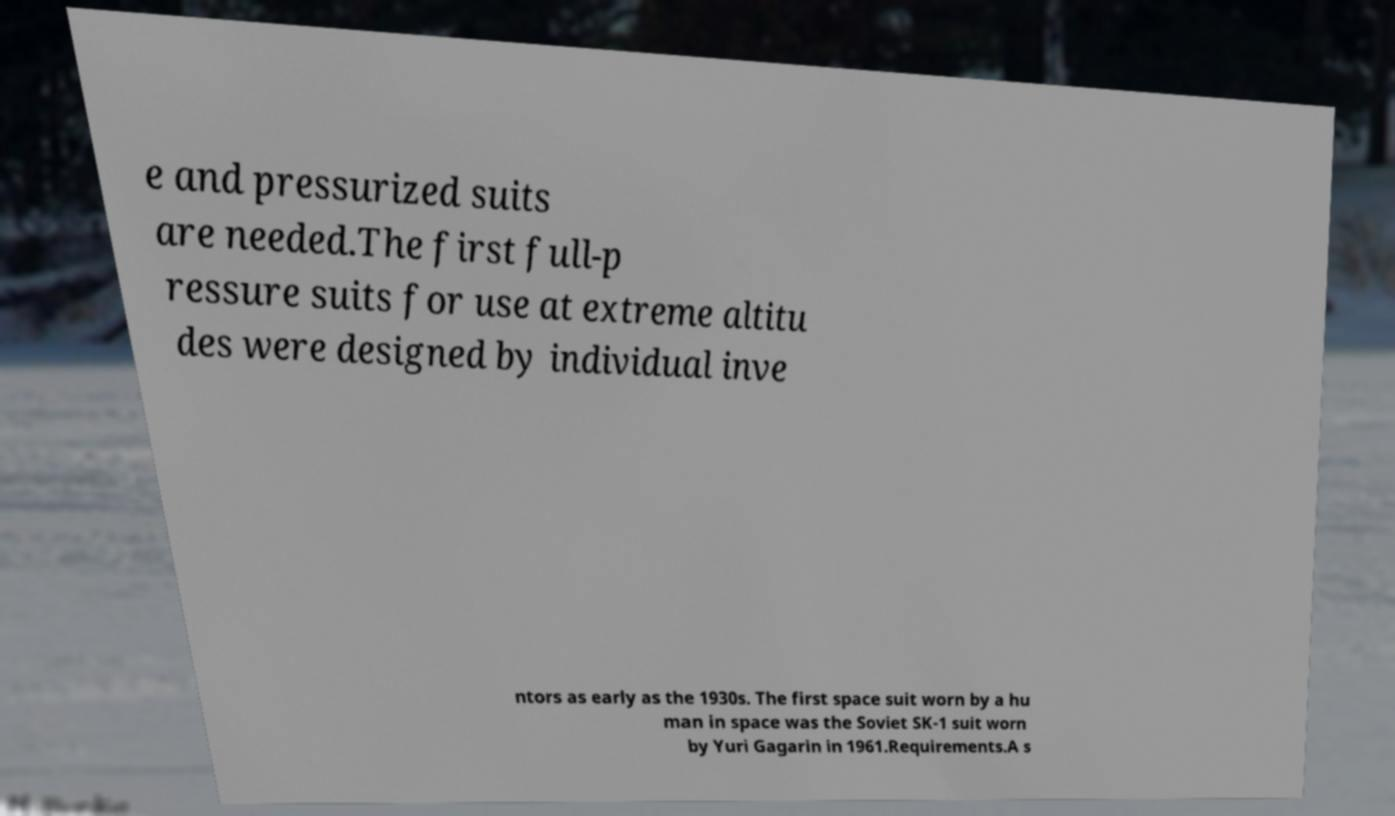Can you accurately transcribe the text from the provided image for me? e and pressurized suits are needed.The first full-p ressure suits for use at extreme altitu des were designed by individual inve ntors as early as the 1930s. The first space suit worn by a hu man in space was the Soviet SK-1 suit worn by Yuri Gagarin in 1961.Requirements.A s 